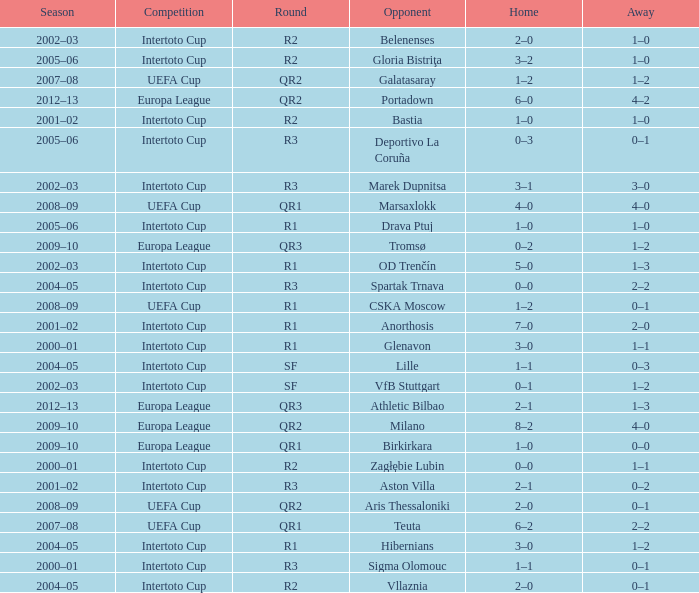What is the home score with marek dupnitsa as opponent? 3–1. 